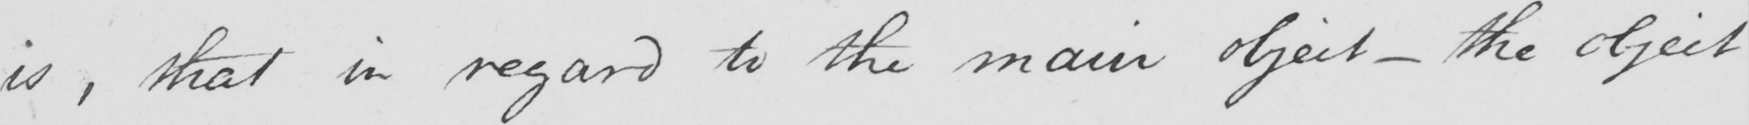What is written in this line of handwriting? is , that in regard to the main object  _  the object 